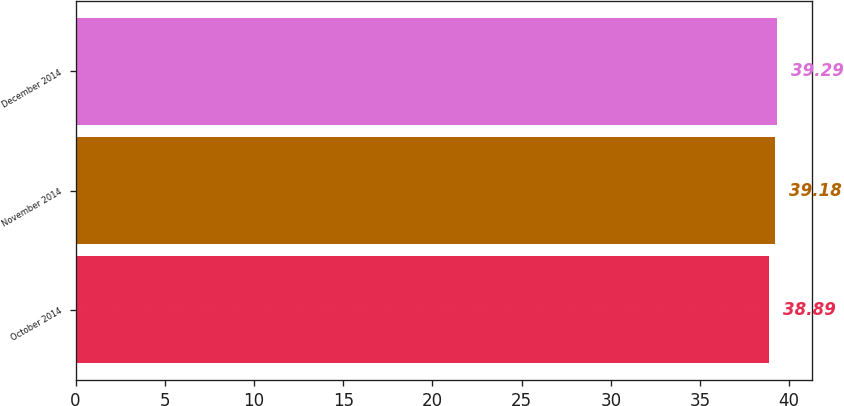Convert chart. <chart><loc_0><loc_0><loc_500><loc_500><bar_chart><fcel>October 2014<fcel>November 2014<fcel>December 2014<nl><fcel>38.89<fcel>39.18<fcel>39.29<nl></chart> 